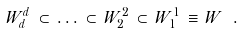Convert formula to latex. <formula><loc_0><loc_0><loc_500><loc_500>W _ { d } ^ { d } \, \subset \, \dots \, \subset \, W ^ { 2 } _ { 2 } \, \subset \, W ^ { 1 } _ { 1 } \, \equiv \, W \ .</formula> 